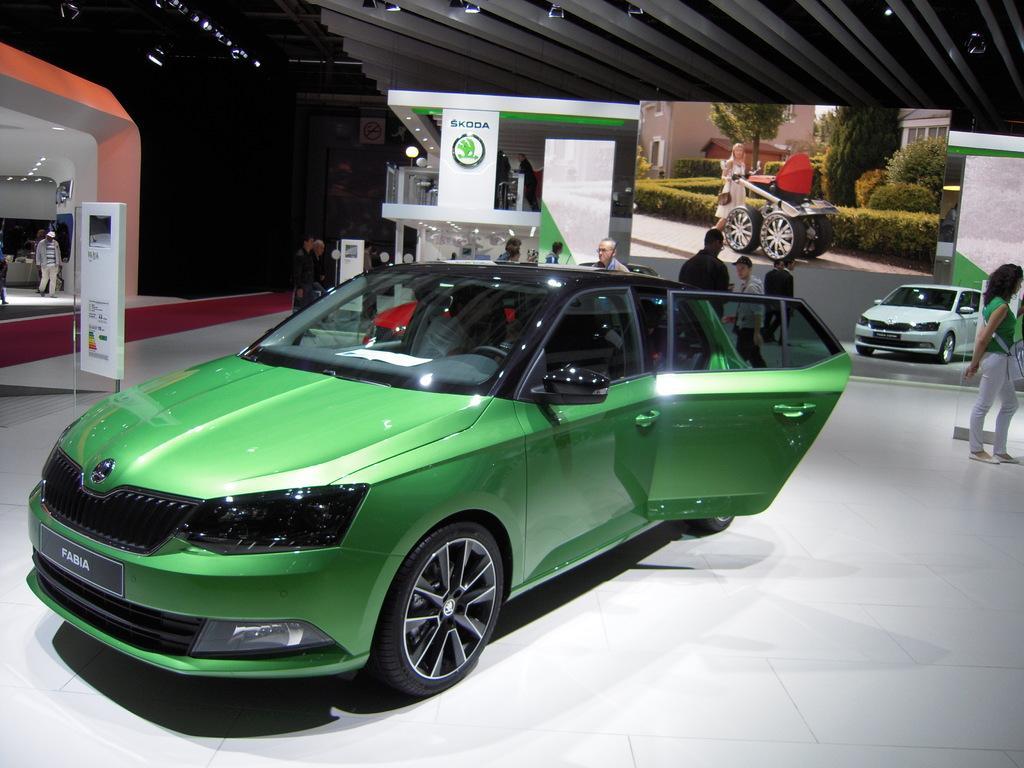Describe this image in one or two sentences. In this image I can see the cars inside the showroom. These cars are in green and white color. I can see few people standing and wearing the different color dresses. In the back there is a screen, banners and the boards. In the top I can see the roof. 